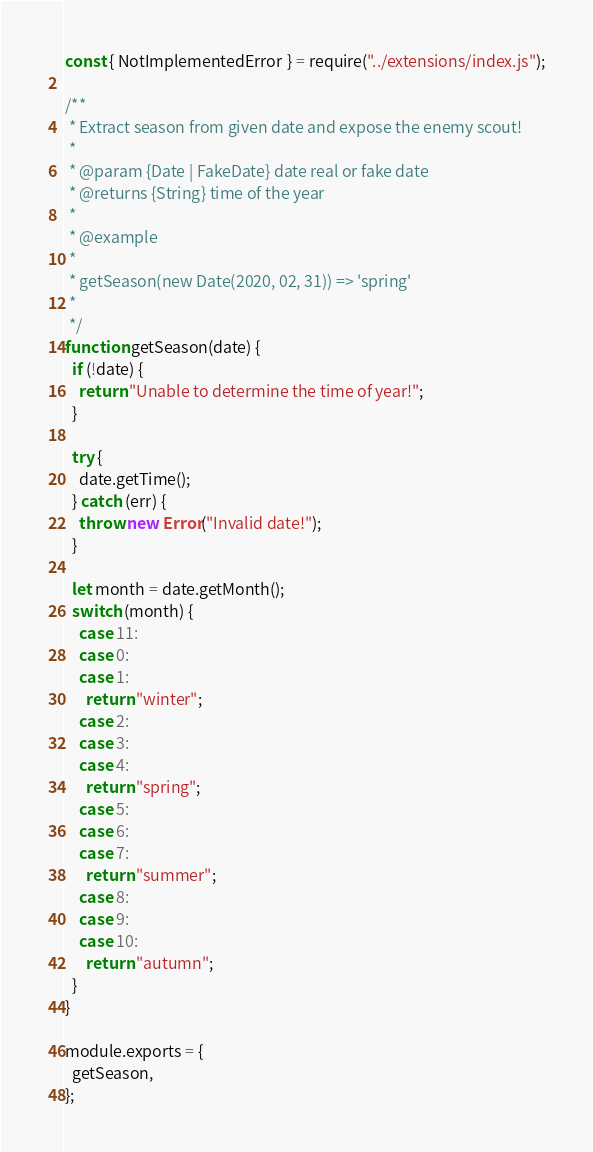<code> <loc_0><loc_0><loc_500><loc_500><_JavaScript_>const { NotImplementedError } = require("../extensions/index.js");

/**
 * Extract season from given date and expose the enemy scout!
 *
 * @param {Date | FakeDate} date real or fake date
 * @returns {String} time of the year
 *
 * @example
 *
 * getSeason(new Date(2020, 02, 31)) => 'spring'
 *
 */
function getSeason(date) {
  if (!date) {
    return "Unable to determine the time of year!";
  }

  try {
    date.getTime();
  } catch (err) {
    throw new Error("Invalid date!");
  }

  let month = date.getMonth();
  switch (month) {
    case 11:
    case 0:
    case 1:
      return "winter";
    case 2:
    case 3:
    case 4:
      return "spring";
    case 5:
    case 6:
    case 7:
      return "summer";
    case 8:
    case 9:
    case 10:
      return "autumn";
  }
}

module.exports = {
  getSeason,
};
</code> 